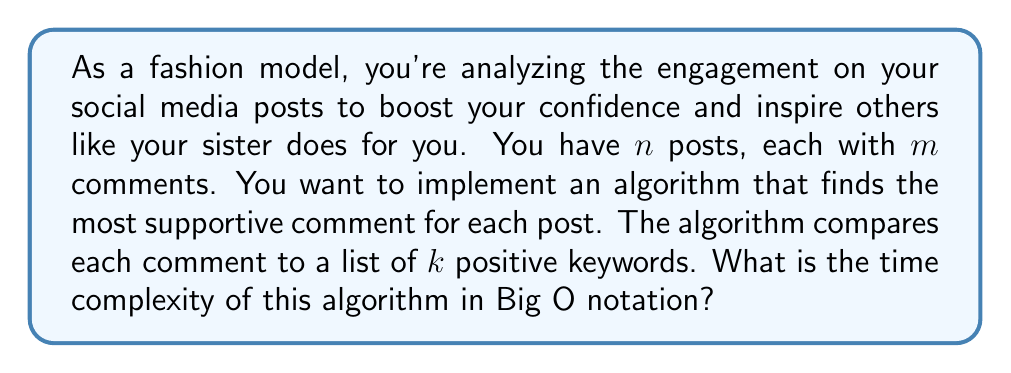Help me with this question. Let's break down the problem and analyze it step by step:

1. We have $n$ posts to analyze.

2. For each post, we need to go through $m$ comments.

3. For each comment, we need to compare it with $k$ positive keywords.

The algorithm structure would look like this:

```
for each post (n times):
    for each comment (m times):
        for each keyword (k times):
            compare comment with keyword
```

This results in a nested loop structure:

- The outermost loop runs $n$ times (for each post)
- The middle loop runs $m$ times (for each comment)
- The innermost loop runs $k$ times (for each keyword)

To find the total number of operations, we multiply these together:

$$\text{Total operations} = n \times m \times k$$

In Big O notation, we express this as:

$$O(nmk)$$

This is because the time complexity grows linearly with each of the three variables $n$, $m$, and $k$.

It's worth noting that if the number of comments ($m$) and keywords ($k$) remain constant regardless of the number of posts, we could simplify this to $O(n)$. However, in a real-world scenario, these values might vary, so it's more accurate to keep the full expression $O(nmk)$.
Answer: $O(nmk)$ 